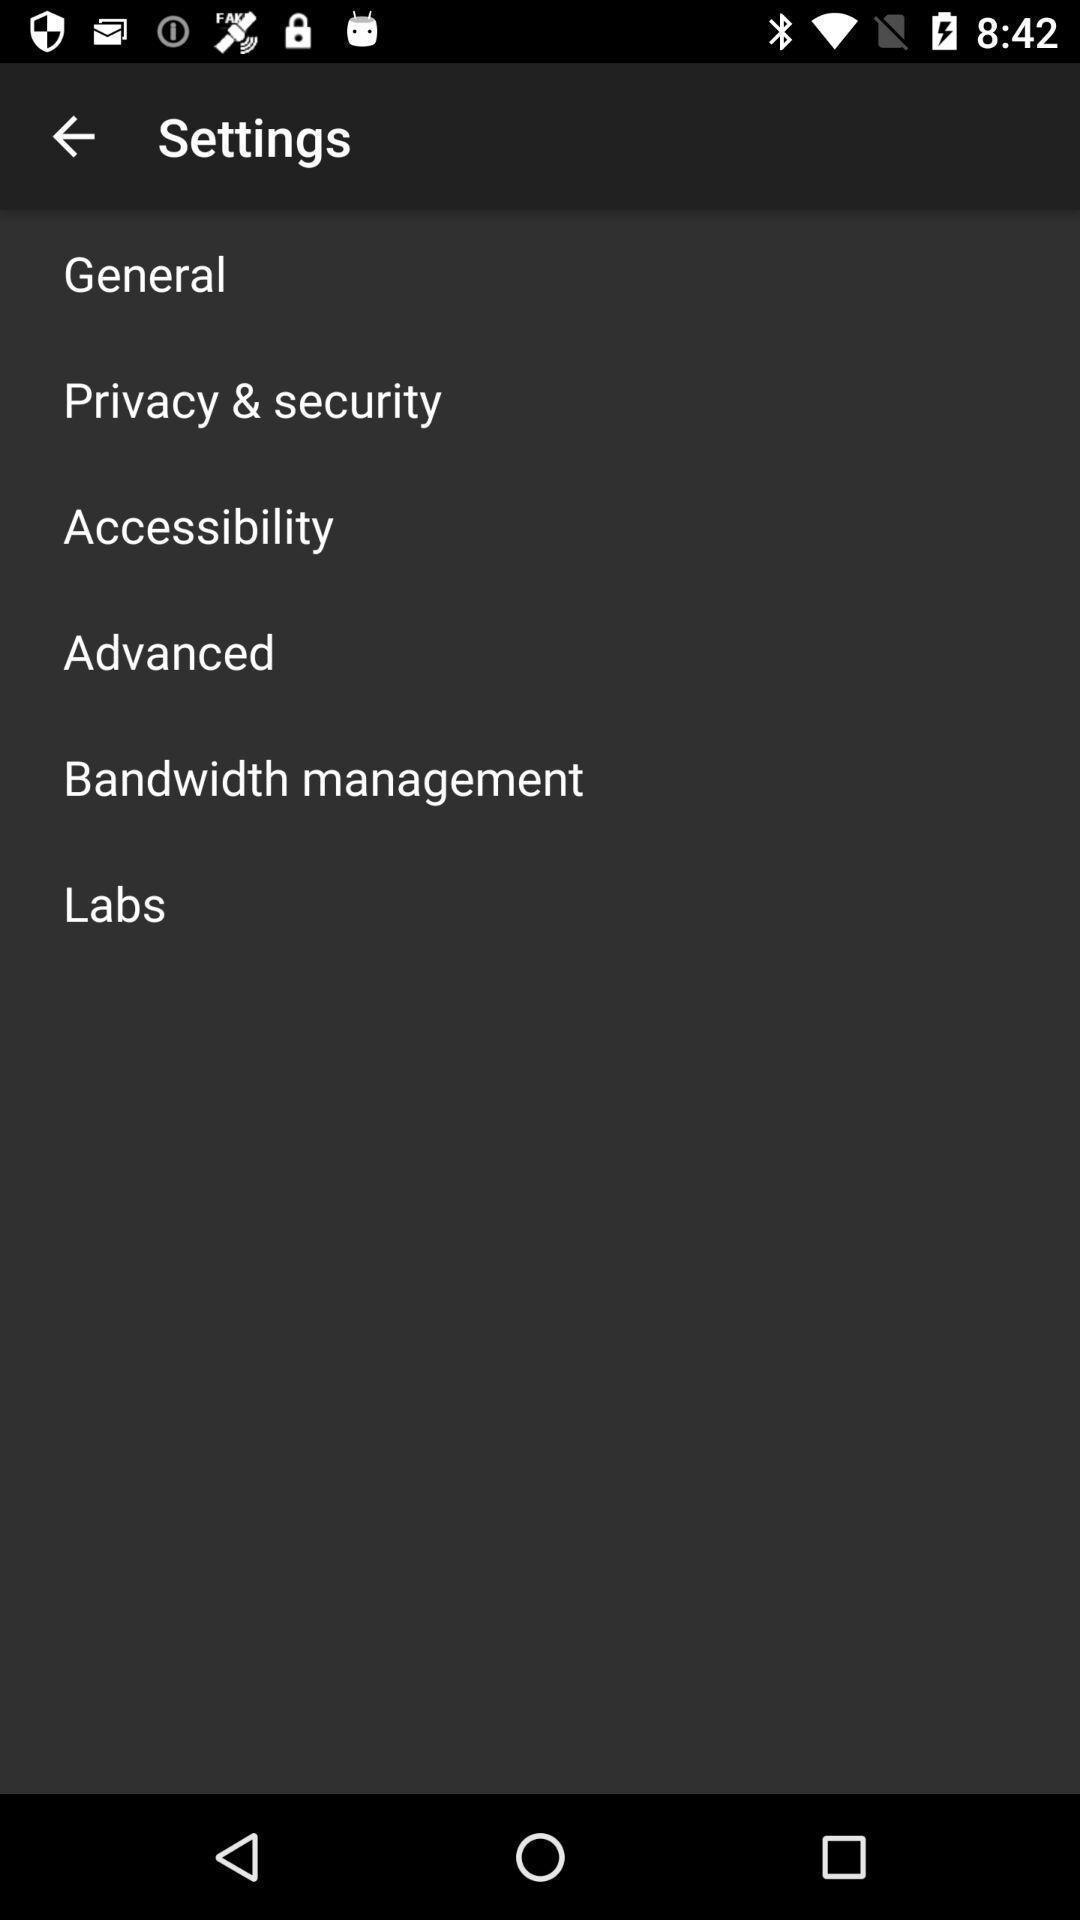Give me a summary of this screen capture. Settings page with various other options in an financial application. 